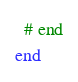Convert code to text. <code><loc_0><loc_0><loc_500><loc_500><_Ruby_>  # end
end
</code> 